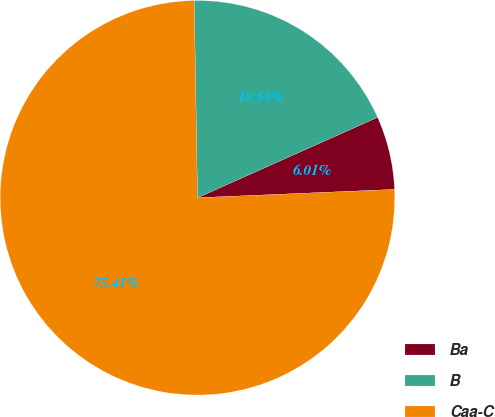Convert chart to OTSL. <chart><loc_0><loc_0><loc_500><loc_500><pie_chart><fcel>Ba<fcel>B<fcel>Caa-C<nl><fcel>6.01%<fcel>18.58%<fcel>75.41%<nl></chart> 